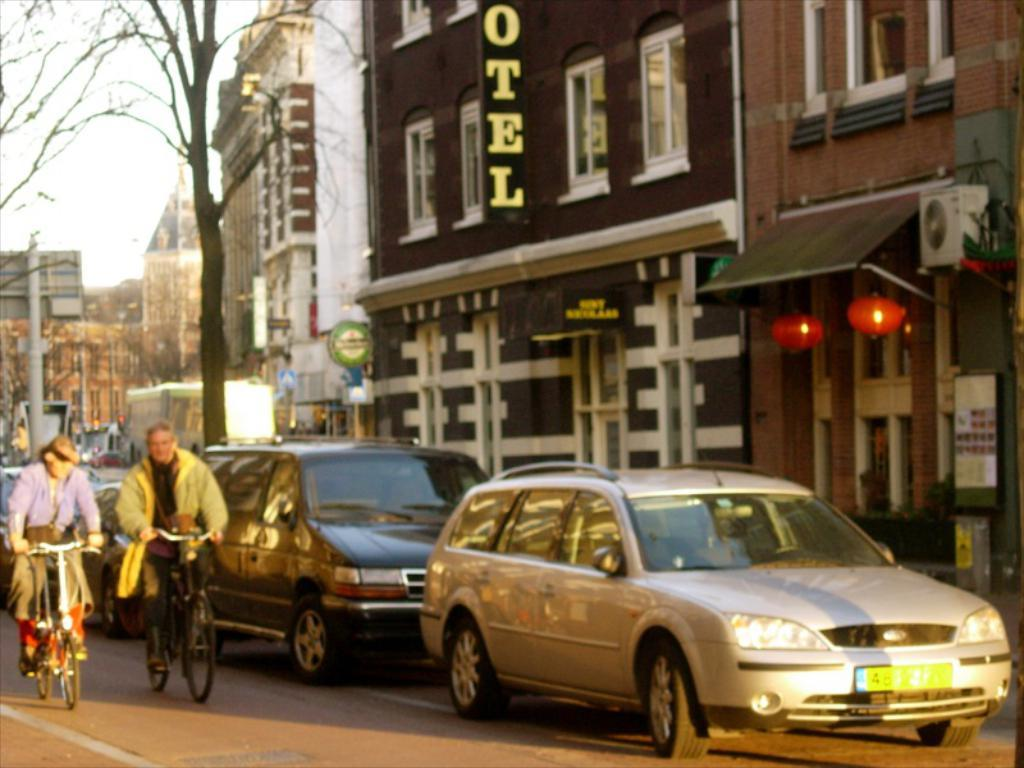<image>
Relay a brief, clear account of the picture shown. A couple riding bicycles down a city street next to a building with a HOTEL sign. 